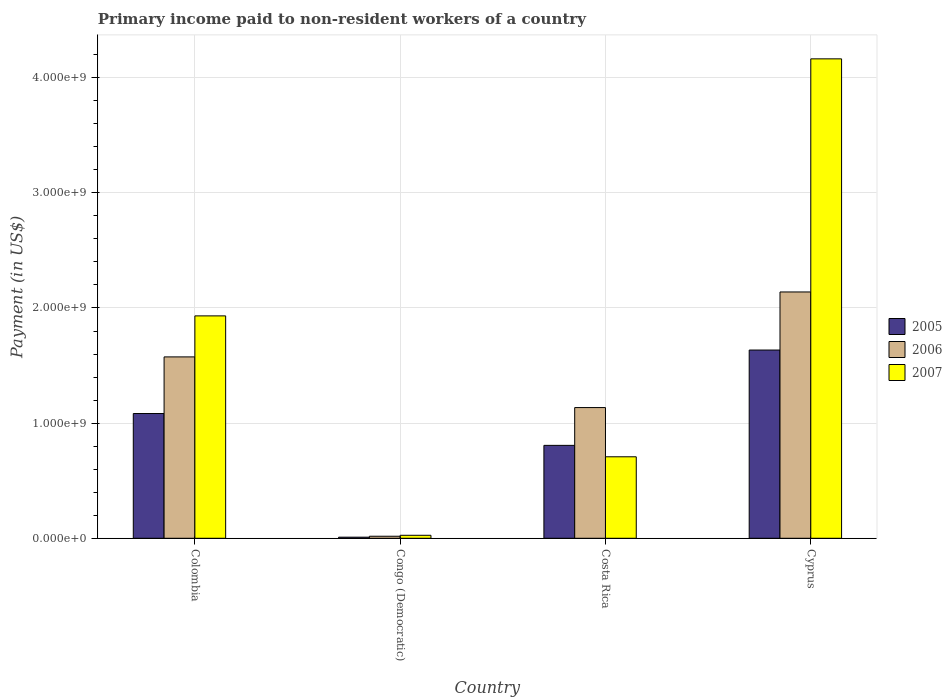How many groups of bars are there?
Offer a very short reply. 4. Are the number of bars per tick equal to the number of legend labels?
Ensure brevity in your answer.  Yes. How many bars are there on the 1st tick from the right?
Your answer should be compact. 3. What is the label of the 3rd group of bars from the left?
Provide a succinct answer. Costa Rica. What is the amount paid to workers in 2006 in Cyprus?
Your answer should be very brief. 2.14e+09. Across all countries, what is the maximum amount paid to workers in 2007?
Your response must be concise. 4.16e+09. Across all countries, what is the minimum amount paid to workers in 2007?
Your answer should be very brief. 2.60e+07. In which country was the amount paid to workers in 2005 maximum?
Ensure brevity in your answer.  Cyprus. In which country was the amount paid to workers in 2005 minimum?
Offer a very short reply. Congo (Democratic). What is the total amount paid to workers in 2007 in the graph?
Your answer should be very brief. 6.83e+09. What is the difference between the amount paid to workers in 2006 in Congo (Democratic) and that in Costa Rica?
Keep it short and to the point. -1.12e+09. What is the difference between the amount paid to workers in 2006 in Colombia and the amount paid to workers in 2007 in Costa Rica?
Offer a very short reply. 8.67e+08. What is the average amount paid to workers in 2006 per country?
Provide a succinct answer. 1.22e+09. What is the difference between the amount paid to workers of/in 2007 and amount paid to workers of/in 2006 in Costa Rica?
Make the answer very short. -4.27e+08. In how many countries, is the amount paid to workers in 2007 greater than 400000000 US$?
Make the answer very short. 3. What is the ratio of the amount paid to workers in 2006 in Colombia to that in Costa Rica?
Give a very brief answer. 1.39. Is the amount paid to workers in 2006 in Colombia less than that in Costa Rica?
Ensure brevity in your answer.  No. What is the difference between the highest and the second highest amount paid to workers in 2007?
Provide a succinct answer. -2.23e+09. What is the difference between the highest and the lowest amount paid to workers in 2006?
Your answer should be compact. 2.12e+09. In how many countries, is the amount paid to workers in 2007 greater than the average amount paid to workers in 2007 taken over all countries?
Keep it short and to the point. 2. Is it the case that in every country, the sum of the amount paid to workers in 2006 and amount paid to workers in 2007 is greater than the amount paid to workers in 2005?
Provide a succinct answer. Yes. How many bars are there?
Give a very brief answer. 12. Are all the bars in the graph horizontal?
Provide a succinct answer. No. Does the graph contain any zero values?
Ensure brevity in your answer.  No. Where does the legend appear in the graph?
Your answer should be very brief. Center right. How are the legend labels stacked?
Provide a short and direct response. Vertical. What is the title of the graph?
Your answer should be very brief. Primary income paid to non-resident workers of a country. What is the label or title of the Y-axis?
Give a very brief answer. Payment (in US$). What is the Payment (in US$) of 2005 in Colombia?
Ensure brevity in your answer.  1.08e+09. What is the Payment (in US$) in 2006 in Colombia?
Your response must be concise. 1.58e+09. What is the Payment (in US$) in 2007 in Colombia?
Provide a short and direct response. 1.93e+09. What is the Payment (in US$) in 2005 in Congo (Democratic)?
Your answer should be very brief. 9.50e+06. What is the Payment (in US$) in 2006 in Congo (Democratic)?
Your answer should be compact. 1.77e+07. What is the Payment (in US$) of 2007 in Congo (Democratic)?
Offer a terse response. 2.60e+07. What is the Payment (in US$) of 2005 in Costa Rica?
Your answer should be very brief. 8.07e+08. What is the Payment (in US$) of 2006 in Costa Rica?
Provide a succinct answer. 1.14e+09. What is the Payment (in US$) in 2007 in Costa Rica?
Give a very brief answer. 7.08e+08. What is the Payment (in US$) in 2005 in Cyprus?
Provide a short and direct response. 1.63e+09. What is the Payment (in US$) of 2006 in Cyprus?
Your response must be concise. 2.14e+09. What is the Payment (in US$) of 2007 in Cyprus?
Offer a very short reply. 4.16e+09. Across all countries, what is the maximum Payment (in US$) of 2005?
Give a very brief answer. 1.63e+09. Across all countries, what is the maximum Payment (in US$) of 2006?
Give a very brief answer. 2.14e+09. Across all countries, what is the maximum Payment (in US$) in 2007?
Provide a short and direct response. 4.16e+09. Across all countries, what is the minimum Payment (in US$) of 2005?
Give a very brief answer. 9.50e+06. Across all countries, what is the minimum Payment (in US$) of 2006?
Give a very brief answer. 1.77e+07. Across all countries, what is the minimum Payment (in US$) of 2007?
Your answer should be very brief. 2.60e+07. What is the total Payment (in US$) in 2005 in the graph?
Offer a very short reply. 3.53e+09. What is the total Payment (in US$) in 2006 in the graph?
Provide a short and direct response. 4.87e+09. What is the total Payment (in US$) in 2007 in the graph?
Give a very brief answer. 6.83e+09. What is the difference between the Payment (in US$) in 2005 in Colombia and that in Congo (Democratic)?
Give a very brief answer. 1.07e+09. What is the difference between the Payment (in US$) in 2006 in Colombia and that in Congo (Democratic)?
Give a very brief answer. 1.56e+09. What is the difference between the Payment (in US$) of 2007 in Colombia and that in Congo (Democratic)?
Make the answer very short. 1.91e+09. What is the difference between the Payment (in US$) of 2005 in Colombia and that in Costa Rica?
Make the answer very short. 2.77e+08. What is the difference between the Payment (in US$) in 2006 in Colombia and that in Costa Rica?
Your response must be concise. 4.40e+08. What is the difference between the Payment (in US$) of 2007 in Colombia and that in Costa Rica?
Offer a terse response. 1.22e+09. What is the difference between the Payment (in US$) in 2005 in Colombia and that in Cyprus?
Your answer should be compact. -5.51e+08. What is the difference between the Payment (in US$) in 2006 in Colombia and that in Cyprus?
Ensure brevity in your answer.  -5.64e+08. What is the difference between the Payment (in US$) of 2007 in Colombia and that in Cyprus?
Make the answer very short. -2.23e+09. What is the difference between the Payment (in US$) of 2005 in Congo (Democratic) and that in Costa Rica?
Ensure brevity in your answer.  -7.97e+08. What is the difference between the Payment (in US$) of 2006 in Congo (Democratic) and that in Costa Rica?
Give a very brief answer. -1.12e+09. What is the difference between the Payment (in US$) of 2007 in Congo (Democratic) and that in Costa Rica?
Offer a terse response. -6.82e+08. What is the difference between the Payment (in US$) in 2005 in Congo (Democratic) and that in Cyprus?
Ensure brevity in your answer.  -1.63e+09. What is the difference between the Payment (in US$) in 2006 in Congo (Democratic) and that in Cyprus?
Provide a succinct answer. -2.12e+09. What is the difference between the Payment (in US$) in 2007 in Congo (Democratic) and that in Cyprus?
Your answer should be very brief. -4.14e+09. What is the difference between the Payment (in US$) of 2005 in Costa Rica and that in Cyprus?
Give a very brief answer. -8.28e+08. What is the difference between the Payment (in US$) in 2006 in Costa Rica and that in Cyprus?
Make the answer very short. -1.00e+09. What is the difference between the Payment (in US$) in 2007 in Costa Rica and that in Cyprus?
Ensure brevity in your answer.  -3.46e+09. What is the difference between the Payment (in US$) of 2005 in Colombia and the Payment (in US$) of 2006 in Congo (Democratic)?
Offer a terse response. 1.07e+09. What is the difference between the Payment (in US$) of 2005 in Colombia and the Payment (in US$) of 2007 in Congo (Democratic)?
Offer a terse response. 1.06e+09. What is the difference between the Payment (in US$) of 2006 in Colombia and the Payment (in US$) of 2007 in Congo (Democratic)?
Offer a terse response. 1.55e+09. What is the difference between the Payment (in US$) in 2005 in Colombia and the Payment (in US$) in 2006 in Costa Rica?
Offer a very short reply. -5.16e+07. What is the difference between the Payment (in US$) in 2005 in Colombia and the Payment (in US$) in 2007 in Costa Rica?
Provide a short and direct response. 3.76e+08. What is the difference between the Payment (in US$) of 2006 in Colombia and the Payment (in US$) of 2007 in Costa Rica?
Offer a very short reply. 8.67e+08. What is the difference between the Payment (in US$) of 2005 in Colombia and the Payment (in US$) of 2006 in Cyprus?
Provide a succinct answer. -1.06e+09. What is the difference between the Payment (in US$) of 2005 in Colombia and the Payment (in US$) of 2007 in Cyprus?
Your answer should be compact. -3.08e+09. What is the difference between the Payment (in US$) in 2006 in Colombia and the Payment (in US$) in 2007 in Cyprus?
Give a very brief answer. -2.59e+09. What is the difference between the Payment (in US$) of 2005 in Congo (Democratic) and the Payment (in US$) of 2006 in Costa Rica?
Provide a short and direct response. -1.13e+09. What is the difference between the Payment (in US$) in 2005 in Congo (Democratic) and the Payment (in US$) in 2007 in Costa Rica?
Your response must be concise. -6.98e+08. What is the difference between the Payment (in US$) of 2006 in Congo (Democratic) and the Payment (in US$) of 2007 in Costa Rica?
Provide a succinct answer. -6.90e+08. What is the difference between the Payment (in US$) in 2005 in Congo (Democratic) and the Payment (in US$) in 2006 in Cyprus?
Keep it short and to the point. -2.13e+09. What is the difference between the Payment (in US$) of 2005 in Congo (Democratic) and the Payment (in US$) of 2007 in Cyprus?
Offer a terse response. -4.15e+09. What is the difference between the Payment (in US$) of 2006 in Congo (Democratic) and the Payment (in US$) of 2007 in Cyprus?
Your response must be concise. -4.15e+09. What is the difference between the Payment (in US$) in 2005 in Costa Rica and the Payment (in US$) in 2006 in Cyprus?
Offer a very short reply. -1.33e+09. What is the difference between the Payment (in US$) in 2005 in Costa Rica and the Payment (in US$) in 2007 in Cyprus?
Keep it short and to the point. -3.36e+09. What is the difference between the Payment (in US$) of 2006 in Costa Rica and the Payment (in US$) of 2007 in Cyprus?
Provide a short and direct response. -3.03e+09. What is the average Payment (in US$) in 2005 per country?
Keep it short and to the point. 8.84e+08. What is the average Payment (in US$) of 2006 per country?
Provide a succinct answer. 1.22e+09. What is the average Payment (in US$) in 2007 per country?
Keep it short and to the point. 1.71e+09. What is the difference between the Payment (in US$) in 2005 and Payment (in US$) in 2006 in Colombia?
Your answer should be very brief. -4.92e+08. What is the difference between the Payment (in US$) in 2005 and Payment (in US$) in 2007 in Colombia?
Keep it short and to the point. -8.48e+08. What is the difference between the Payment (in US$) of 2006 and Payment (in US$) of 2007 in Colombia?
Your response must be concise. -3.56e+08. What is the difference between the Payment (in US$) of 2005 and Payment (in US$) of 2006 in Congo (Democratic)?
Offer a terse response. -8.20e+06. What is the difference between the Payment (in US$) in 2005 and Payment (in US$) in 2007 in Congo (Democratic)?
Keep it short and to the point. -1.65e+07. What is the difference between the Payment (in US$) of 2006 and Payment (in US$) of 2007 in Congo (Democratic)?
Your answer should be very brief. -8.30e+06. What is the difference between the Payment (in US$) in 2005 and Payment (in US$) in 2006 in Costa Rica?
Your answer should be very brief. -3.28e+08. What is the difference between the Payment (in US$) in 2005 and Payment (in US$) in 2007 in Costa Rica?
Provide a succinct answer. 9.92e+07. What is the difference between the Payment (in US$) of 2006 and Payment (in US$) of 2007 in Costa Rica?
Provide a short and direct response. 4.27e+08. What is the difference between the Payment (in US$) of 2005 and Payment (in US$) of 2006 in Cyprus?
Your answer should be very brief. -5.04e+08. What is the difference between the Payment (in US$) in 2005 and Payment (in US$) in 2007 in Cyprus?
Provide a short and direct response. -2.53e+09. What is the difference between the Payment (in US$) of 2006 and Payment (in US$) of 2007 in Cyprus?
Give a very brief answer. -2.02e+09. What is the ratio of the Payment (in US$) of 2005 in Colombia to that in Congo (Democratic)?
Give a very brief answer. 114.05. What is the ratio of the Payment (in US$) of 2006 in Colombia to that in Congo (Democratic)?
Ensure brevity in your answer.  88.99. What is the ratio of the Payment (in US$) of 2007 in Colombia to that in Congo (Democratic)?
Offer a terse response. 74.28. What is the ratio of the Payment (in US$) in 2005 in Colombia to that in Costa Rica?
Your answer should be compact. 1.34. What is the ratio of the Payment (in US$) of 2006 in Colombia to that in Costa Rica?
Provide a succinct answer. 1.39. What is the ratio of the Payment (in US$) in 2007 in Colombia to that in Costa Rica?
Offer a very short reply. 2.73. What is the ratio of the Payment (in US$) in 2005 in Colombia to that in Cyprus?
Your answer should be compact. 0.66. What is the ratio of the Payment (in US$) of 2006 in Colombia to that in Cyprus?
Keep it short and to the point. 0.74. What is the ratio of the Payment (in US$) in 2007 in Colombia to that in Cyprus?
Provide a succinct answer. 0.46. What is the ratio of the Payment (in US$) in 2005 in Congo (Democratic) to that in Costa Rica?
Make the answer very short. 0.01. What is the ratio of the Payment (in US$) in 2006 in Congo (Democratic) to that in Costa Rica?
Your response must be concise. 0.02. What is the ratio of the Payment (in US$) in 2007 in Congo (Democratic) to that in Costa Rica?
Give a very brief answer. 0.04. What is the ratio of the Payment (in US$) of 2005 in Congo (Democratic) to that in Cyprus?
Your response must be concise. 0.01. What is the ratio of the Payment (in US$) in 2006 in Congo (Democratic) to that in Cyprus?
Your answer should be compact. 0.01. What is the ratio of the Payment (in US$) of 2007 in Congo (Democratic) to that in Cyprus?
Offer a terse response. 0.01. What is the ratio of the Payment (in US$) of 2005 in Costa Rica to that in Cyprus?
Provide a succinct answer. 0.49. What is the ratio of the Payment (in US$) in 2006 in Costa Rica to that in Cyprus?
Keep it short and to the point. 0.53. What is the ratio of the Payment (in US$) of 2007 in Costa Rica to that in Cyprus?
Offer a very short reply. 0.17. What is the difference between the highest and the second highest Payment (in US$) of 2005?
Make the answer very short. 5.51e+08. What is the difference between the highest and the second highest Payment (in US$) of 2006?
Your answer should be very brief. 5.64e+08. What is the difference between the highest and the second highest Payment (in US$) of 2007?
Your response must be concise. 2.23e+09. What is the difference between the highest and the lowest Payment (in US$) in 2005?
Offer a very short reply. 1.63e+09. What is the difference between the highest and the lowest Payment (in US$) of 2006?
Your response must be concise. 2.12e+09. What is the difference between the highest and the lowest Payment (in US$) of 2007?
Offer a terse response. 4.14e+09. 